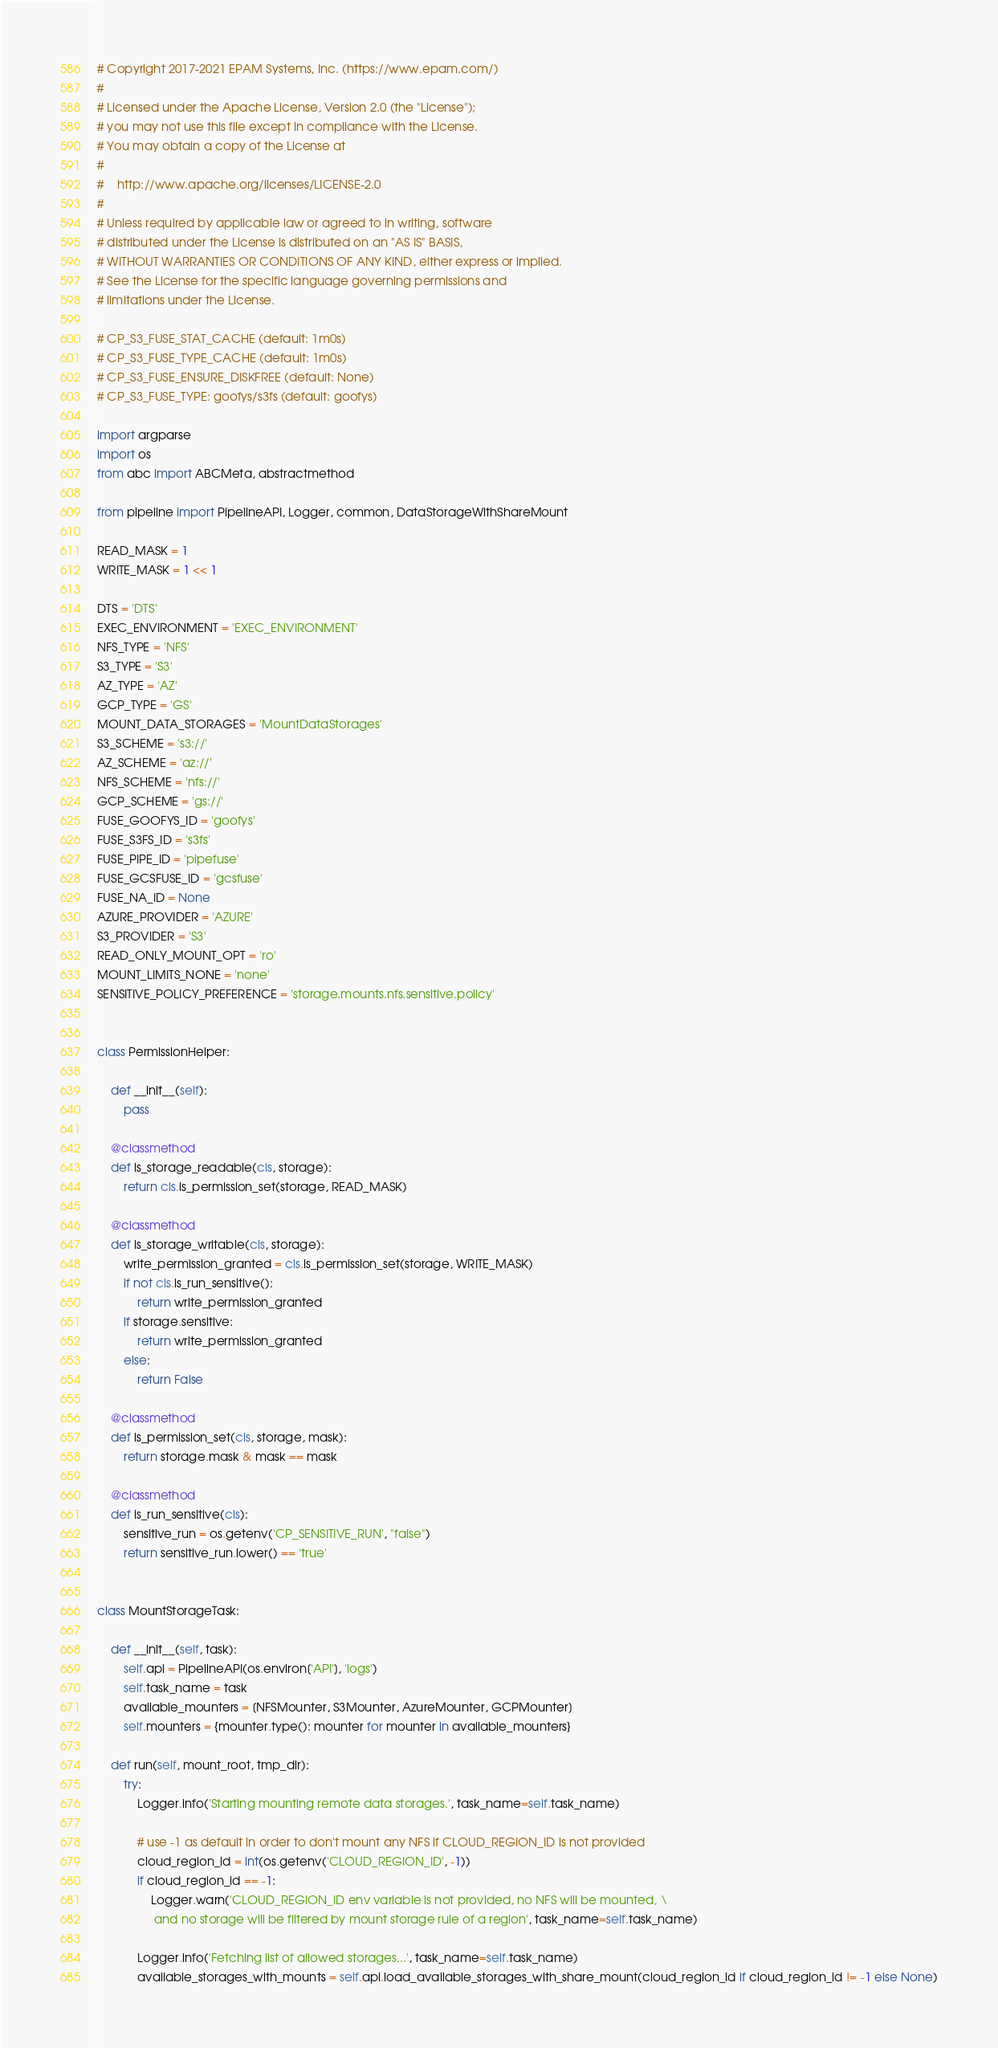Convert code to text. <code><loc_0><loc_0><loc_500><loc_500><_Python_># Copyright 2017-2021 EPAM Systems, Inc. (https://www.epam.com/)
#
# Licensed under the Apache License, Version 2.0 (the "License");
# you may not use this file except in compliance with the License.
# You may obtain a copy of the License at
#
#    http://www.apache.org/licenses/LICENSE-2.0
#
# Unless required by applicable law or agreed to in writing, software
# distributed under the License is distributed on an "AS IS" BASIS,
# WITHOUT WARRANTIES OR CONDITIONS OF ANY KIND, either express or implied.
# See the License for the specific language governing permissions and
# limitations under the License.

# CP_S3_FUSE_STAT_CACHE (default: 1m0s)
# CP_S3_FUSE_TYPE_CACHE (default: 1m0s)
# CP_S3_FUSE_ENSURE_DISKFREE (default: None)
# CP_S3_FUSE_TYPE: goofys/s3fs (default: goofys)

import argparse
import os
from abc import ABCMeta, abstractmethod

from pipeline import PipelineAPI, Logger, common, DataStorageWithShareMount

READ_MASK = 1
WRITE_MASK = 1 << 1

DTS = 'DTS'
EXEC_ENVIRONMENT = 'EXEC_ENVIRONMENT'
NFS_TYPE = 'NFS'
S3_TYPE = 'S3'
AZ_TYPE = 'AZ'
GCP_TYPE = 'GS'
MOUNT_DATA_STORAGES = 'MountDataStorages'
S3_SCHEME = 's3://'
AZ_SCHEME = 'az://'
NFS_SCHEME = 'nfs://'
GCP_SCHEME = 'gs://'
FUSE_GOOFYS_ID = 'goofys'
FUSE_S3FS_ID = 's3fs'
FUSE_PIPE_ID = 'pipefuse'
FUSE_GCSFUSE_ID = 'gcsfuse'
FUSE_NA_ID = None
AZURE_PROVIDER = 'AZURE'
S3_PROVIDER = 'S3'
READ_ONLY_MOUNT_OPT = 'ro'
MOUNT_LIMITS_NONE = 'none'
SENSITIVE_POLICY_PREFERENCE = 'storage.mounts.nfs.sensitive.policy'


class PermissionHelper:

    def __init__(self):
        pass

    @classmethod
    def is_storage_readable(cls, storage):
        return cls.is_permission_set(storage, READ_MASK)

    @classmethod
    def is_storage_writable(cls, storage):
        write_permission_granted = cls.is_permission_set(storage, WRITE_MASK)
        if not cls.is_run_sensitive():
            return write_permission_granted
        if storage.sensitive:
            return write_permission_granted
        else:
            return False

    @classmethod
    def is_permission_set(cls, storage, mask):
        return storage.mask & mask == mask

    @classmethod
    def is_run_sensitive(cls):
        sensitive_run = os.getenv('CP_SENSITIVE_RUN', "false")
        return sensitive_run.lower() == 'true'


class MountStorageTask:

    def __init__(self, task):
        self.api = PipelineAPI(os.environ['API'], 'logs')
        self.task_name = task
        available_mounters = [NFSMounter, S3Mounter, AzureMounter, GCPMounter]
        self.mounters = {mounter.type(): mounter for mounter in available_mounters}

    def run(self, mount_root, tmp_dir):
        try:
            Logger.info('Starting mounting remote data storages.', task_name=self.task_name)

            # use -1 as default in order to don't mount any NFS if CLOUD_REGION_ID is not provided
            cloud_region_id = int(os.getenv('CLOUD_REGION_ID', -1))
            if cloud_region_id == -1:
                Logger.warn('CLOUD_REGION_ID env variable is not provided, no NFS will be mounted, \
                 and no storage will be filtered by mount storage rule of a region', task_name=self.task_name)

            Logger.info('Fetching list of allowed storages...', task_name=self.task_name)
            available_storages_with_mounts = self.api.load_available_storages_with_share_mount(cloud_region_id if cloud_region_id != -1 else None)</code> 